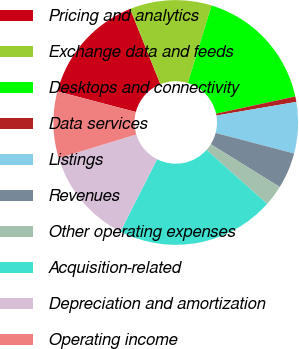Convert chart. <chart><loc_0><loc_0><loc_500><loc_500><pie_chart><fcel>Pricing and analytics<fcel>Exchange data and feeds<fcel>Desktops and connectivity<fcel>Data services<fcel>Listings<fcel>Revenues<fcel>Other operating expenses<fcel>Acquisition-related<fcel>Depreciation and amortization<fcel>Operating income<nl><fcel>14.84%<fcel>10.81%<fcel>16.86%<fcel>0.72%<fcel>6.77%<fcel>4.76%<fcel>2.74%<fcel>20.89%<fcel>12.82%<fcel>8.79%<nl></chart> 